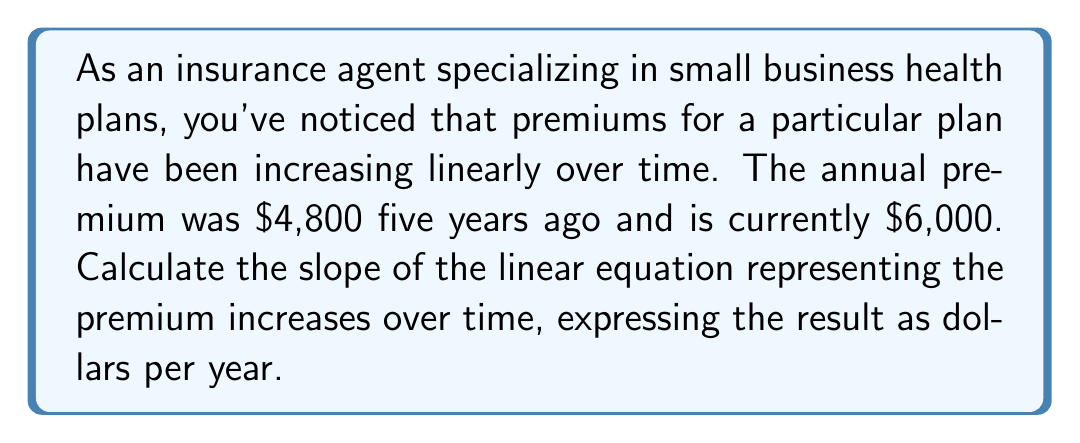Show me your answer to this math problem. To calculate the slope of the linear equation representing premium increases over time, we'll use the slope formula:

$$ m = \frac{y_2 - y_1}{x_2 - x_1} $$

Where:
- $m$ is the slope
- $(x_1, y_1)$ is the first point (5 years ago, $4,800)
- $(x_2, y_2)$ is the second point (current year, $6,000)

Let's define our points:
- $(x_1, y_1) = (0, 4800)$
- $(x_2, y_2) = (5, 6000)$

Now, let's plug these values into the slope formula:

$$ m = \frac{6000 - 4800}{5 - 0} $$

$$ m = \frac{1200}{5} $$

$$ m = 240 $$

The slope represents the rate of change in premiums per year. In this case, it's $240 per year.
Answer: The slope of the linear equation representing premium increases over time is $240 per year. 